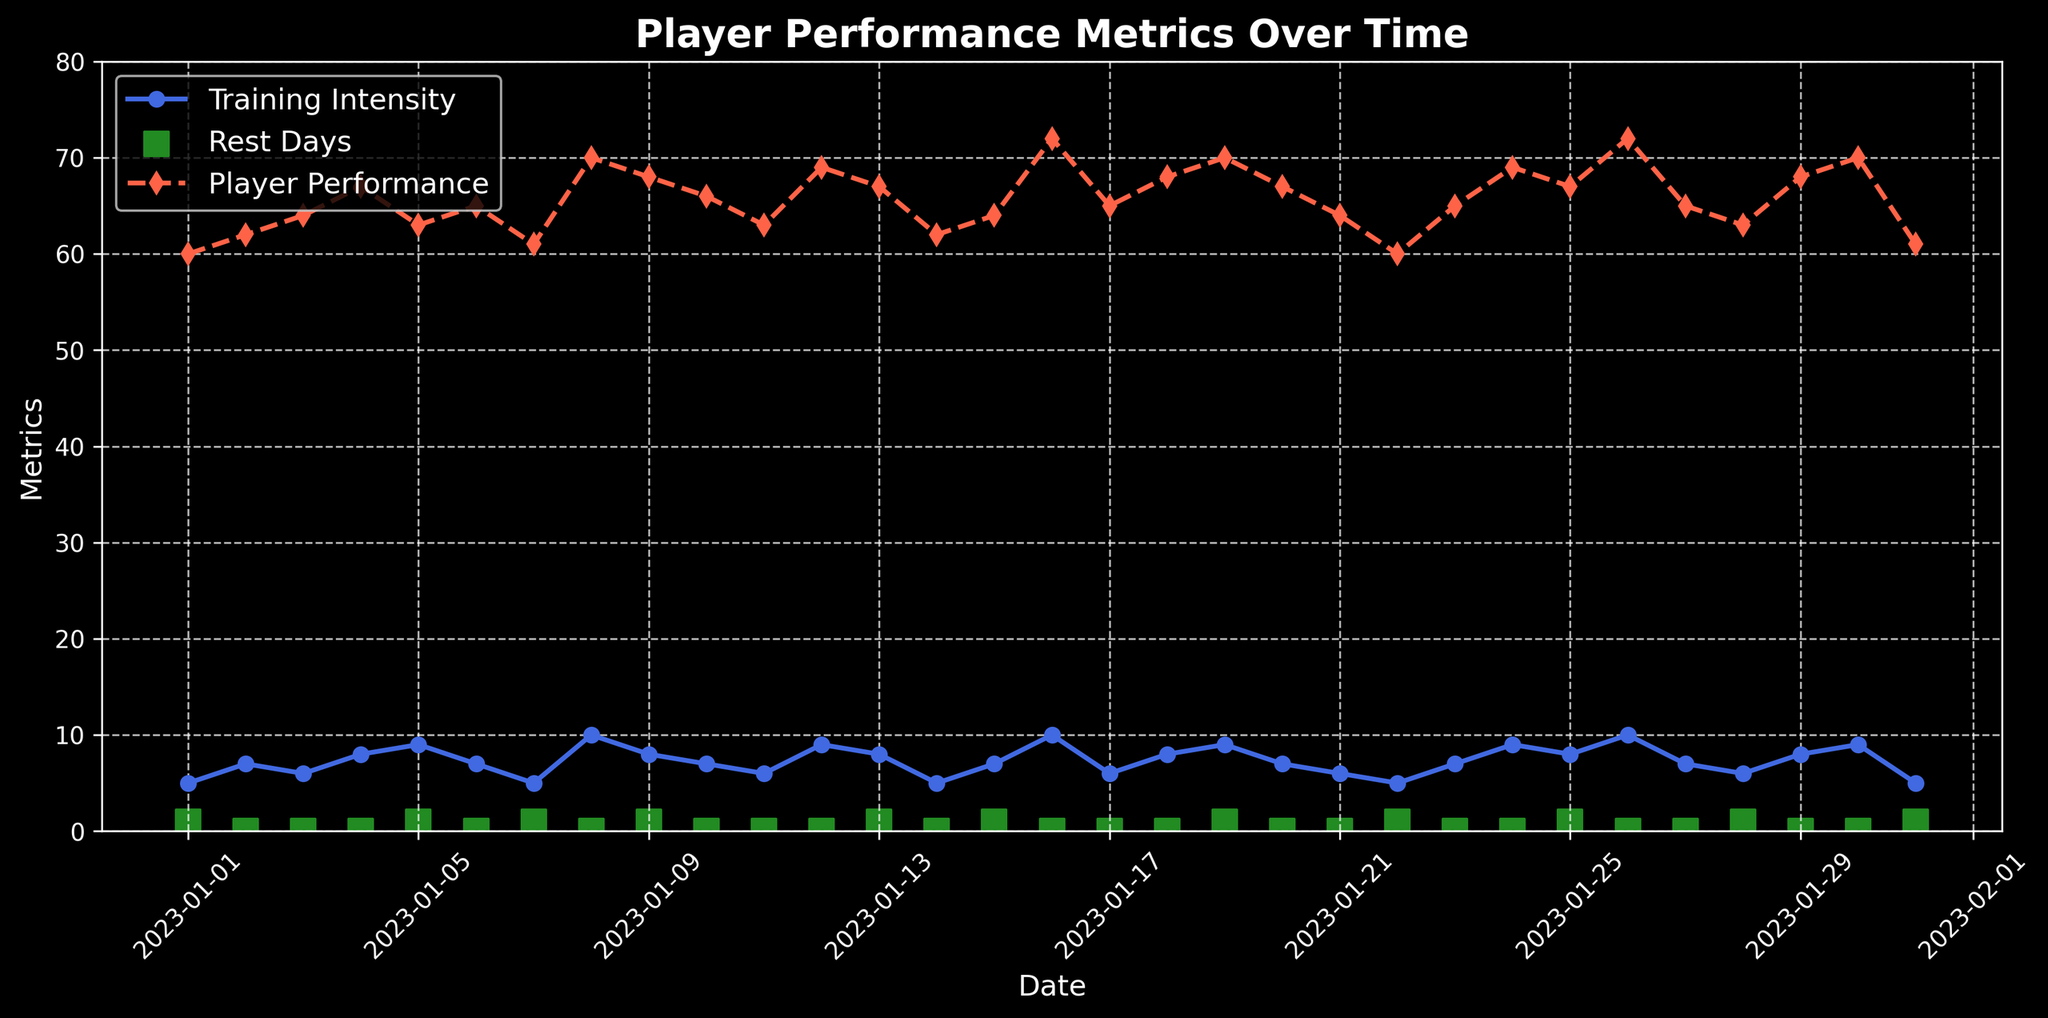What date corresponds to the highest Player Performance? Look for the highest point on the Player Performance (red) line and trace it to the corresponding date on the x-axis.
Answer: 2023-01-16 Which date had the lowest training intensity? Identify the lowest point on the Training Intensity (blue) line and match it with its specific date on the x-axis.
Answer: 2023-01-01 How many rest days are there in total in January 2023? Count the number of green squares on the plot for rest days.
Answer: 7 On which date did the Player Performance drop the most compared to the previous day? Find the sharpest decrease in the Player Performance line (red dashes) by comparing the heights of successive points.
Answer: 2023-01-05 What is the average Training Intensity on dates where Player Performance is above 65? Look for dates where the Player Performance (red line) is above 65, check the corresponding Training Intensity values (blue line), sum them, and divide by the count.
Answer: 8.25 What were the Player Performance values on days without rest? Identify points on the Player Performance (red) line that correspond to the Rest Days (green squares) at 0 and list those values.
Answer: 62, 64, 67, 65, 70, 66, 63, 69, 72, 65, 68, 70, 72, 65, 68, 70 Is there a noticeable trend in Player Performance when Training Intensity is 10? Check the points on the Player Performance (red) line corresponding to Training Intensity (blue) at 10 and note the pattern.
Answer: Increasing What was the Training Intensity and Player Performance on 2023-01-19? Locate the data points for Training Intensity (blue) and Player Performance (red) directly above the date 2023-01-19.
Answer: 9, 70 Compare the average Player Performance on rest days and no rest days. Separate Player Performance values into two groups (with rest and without rest), find the average for each group, and compare.
Answer: Rest: 64.29, No rest: 66.81 On which dates do the Player Performance and Rest Days both peak simultaneously? Look for overlap in peaks between green squares (Rest Days) and highest points on the red line (Player Performance).
Answer: None 